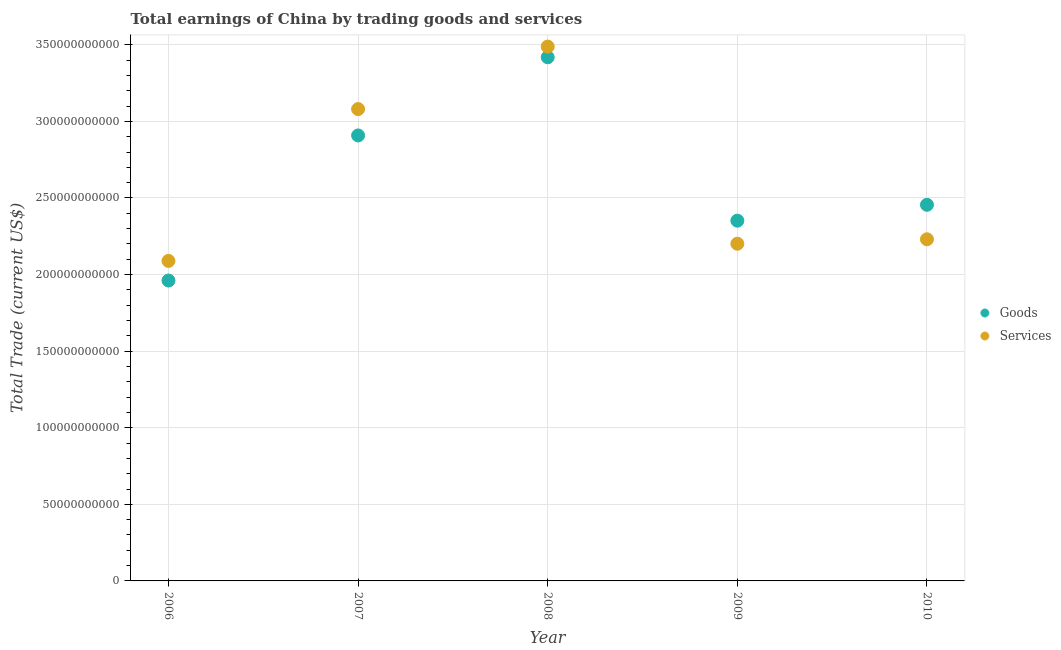What is the amount earned by trading services in 2007?
Provide a succinct answer. 3.08e+11. Across all years, what is the maximum amount earned by trading services?
Offer a terse response. 3.49e+11. Across all years, what is the minimum amount earned by trading goods?
Ensure brevity in your answer.  1.96e+11. In which year was the amount earned by trading goods maximum?
Offer a terse response. 2008. What is the total amount earned by trading goods in the graph?
Provide a succinct answer. 1.31e+12. What is the difference between the amount earned by trading services in 2006 and that in 2010?
Provide a succinct answer. -1.41e+1. What is the difference between the amount earned by trading goods in 2007 and the amount earned by trading services in 2008?
Provide a succinct answer. -5.80e+1. What is the average amount earned by trading services per year?
Your response must be concise. 2.62e+11. In the year 2006, what is the difference between the amount earned by trading goods and amount earned by trading services?
Offer a terse response. -1.28e+1. In how many years, is the amount earned by trading goods greater than 330000000000 US$?
Provide a succinct answer. 1. What is the ratio of the amount earned by trading services in 2007 to that in 2008?
Your response must be concise. 0.88. Is the amount earned by trading goods in 2006 less than that in 2010?
Provide a succinct answer. Yes. Is the difference between the amount earned by trading goods in 2006 and 2007 greater than the difference between the amount earned by trading services in 2006 and 2007?
Your answer should be very brief. Yes. What is the difference between the highest and the second highest amount earned by trading goods?
Your response must be concise. 5.10e+1. What is the difference between the highest and the lowest amount earned by trading services?
Keep it short and to the point. 1.40e+11. Is the sum of the amount earned by trading services in 2009 and 2010 greater than the maximum amount earned by trading goods across all years?
Give a very brief answer. Yes. Does the amount earned by trading goods monotonically increase over the years?
Keep it short and to the point. No. Is the amount earned by trading goods strictly greater than the amount earned by trading services over the years?
Give a very brief answer. No. How many years are there in the graph?
Keep it short and to the point. 5. What is the difference between two consecutive major ticks on the Y-axis?
Make the answer very short. 5.00e+1. Does the graph contain any zero values?
Make the answer very short. No. What is the title of the graph?
Your answer should be compact. Total earnings of China by trading goods and services. Does "National Visitors" appear as one of the legend labels in the graph?
Offer a very short reply. No. What is the label or title of the X-axis?
Offer a terse response. Year. What is the label or title of the Y-axis?
Offer a terse response. Total Trade (current US$). What is the Total Trade (current US$) of Goods in 2006?
Give a very brief answer. 1.96e+11. What is the Total Trade (current US$) in Services in 2006?
Ensure brevity in your answer.  2.09e+11. What is the Total Trade (current US$) of Goods in 2007?
Provide a succinct answer. 2.91e+11. What is the Total Trade (current US$) in Services in 2007?
Ensure brevity in your answer.  3.08e+11. What is the Total Trade (current US$) in Goods in 2008?
Keep it short and to the point. 3.42e+11. What is the Total Trade (current US$) in Services in 2008?
Your response must be concise. 3.49e+11. What is the Total Trade (current US$) in Goods in 2009?
Provide a succinct answer. 2.35e+11. What is the Total Trade (current US$) of Services in 2009?
Ensure brevity in your answer.  2.20e+11. What is the Total Trade (current US$) of Goods in 2010?
Provide a short and direct response. 2.46e+11. What is the Total Trade (current US$) in Services in 2010?
Ensure brevity in your answer.  2.23e+11. Across all years, what is the maximum Total Trade (current US$) of Goods?
Provide a succinct answer. 3.42e+11. Across all years, what is the maximum Total Trade (current US$) of Services?
Ensure brevity in your answer.  3.49e+11. Across all years, what is the minimum Total Trade (current US$) in Goods?
Your answer should be very brief. 1.96e+11. Across all years, what is the minimum Total Trade (current US$) in Services?
Make the answer very short. 2.09e+11. What is the total Total Trade (current US$) in Goods in the graph?
Your answer should be very brief. 1.31e+12. What is the total Total Trade (current US$) of Services in the graph?
Your answer should be very brief. 1.31e+12. What is the difference between the Total Trade (current US$) in Goods in 2006 and that in 2007?
Keep it short and to the point. -9.47e+1. What is the difference between the Total Trade (current US$) of Services in 2006 and that in 2007?
Offer a very short reply. -9.91e+1. What is the difference between the Total Trade (current US$) in Goods in 2006 and that in 2008?
Provide a short and direct response. -1.46e+11. What is the difference between the Total Trade (current US$) in Services in 2006 and that in 2008?
Your answer should be very brief. -1.40e+11. What is the difference between the Total Trade (current US$) in Goods in 2006 and that in 2009?
Give a very brief answer. -3.91e+1. What is the difference between the Total Trade (current US$) in Services in 2006 and that in 2009?
Provide a succinct answer. -1.12e+1. What is the difference between the Total Trade (current US$) in Goods in 2006 and that in 2010?
Offer a terse response. -4.94e+1. What is the difference between the Total Trade (current US$) of Services in 2006 and that in 2010?
Provide a succinct answer. -1.41e+1. What is the difference between the Total Trade (current US$) of Goods in 2007 and that in 2008?
Keep it short and to the point. -5.10e+1. What is the difference between the Total Trade (current US$) in Services in 2007 and that in 2008?
Offer a very short reply. -4.08e+1. What is the difference between the Total Trade (current US$) of Goods in 2007 and that in 2009?
Provide a short and direct response. 5.56e+1. What is the difference between the Total Trade (current US$) of Services in 2007 and that in 2009?
Provide a short and direct response. 8.79e+1. What is the difference between the Total Trade (current US$) of Goods in 2007 and that in 2010?
Give a very brief answer. 4.53e+1. What is the difference between the Total Trade (current US$) in Services in 2007 and that in 2010?
Offer a terse response. 8.50e+1. What is the difference between the Total Trade (current US$) in Goods in 2008 and that in 2009?
Ensure brevity in your answer.  1.07e+11. What is the difference between the Total Trade (current US$) in Services in 2008 and that in 2009?
Your response must be concise. 1.29e+11. What is the difference between the Total Trade (current US$) of Goods in 2008 and that in 2010?
Offer a terse response. 9.63e+1. What is the difference between the Total Trade (current US$) of Services in 2008 and that in 2010?
Make the answer very short. 1.26e+11. What is the difference between the Total Trade (current US$) of Goods in 2009 and that in 2010?
Offer a terse response. -1.04e+1. What is the difference between the Total Trade (current US$) of Services in 2009 and that in 2010?
Your response must be concise. -2.89e+09. What is the difference between the Total Trade (current US$) of Goods in 2006 and the Total Trade (current US$) of Services in 2007?
Offer a terse response. -1.12e+11. What is the difference between the Total Trade (current US$) of Goods in 2006 and the Total Trade (current US$) of Services in 2008?
Offer a terse response. -1.53e+11. What is the difference between the Total Trade (current US$) in Goods in 2006 and the Total Trade (current US$) in Services in 2009?
Provide a short and direct response. -2.40e+1. What is the difference between the Total Trade (current US$) in Goods in 2006 and the Total Trade (current US$) in Services in 2010?
Provide a succinct answer. -2.69e+1. What is the difference between the Total Trade (current US$) of Goods in 2007 and the Total Trade (current US$) of Services in 2008?
Provide a short and direct response. -5.80e+1. What is the difference between the Total Trade (current US$) of Goods in 2007 and the Total Trade (current US$) of Services in 2009?
Give a very brief answer. 7.07e+1. What is the difference between the Total Trade (current US$) of Goods in 2007 and the Total Trade (current US$) of Services in 2010?
Your answer should be compact. 6.78e+1. What is the difference between the Total Trade (current US$) in Goods in 2008 and the Total Trade (current US$) in Services in 2009?
Your answer should be compact. 1.22e+11. What is the difference between the Total Trade (current US$) of Goods in 2008 and the Total Trade (current US$) of Services in 2010?
Provide a succinct answer. 1.19e+11. What is the difference between the Total Trade (current US$) in Goods in 2009 and the Total Trade (current US$) in Services in 2010?
Give a very brief answer. 1.22e+1. What is the average Total Trade (current US$) of Goods per year?
Make the answer very short. 2.62e+11. What is the average Total Trade (current US$) of Services per year?
Provide a short and direct response. 2.62e+11. In the year 2006, what is the difference between the Total Trade (current US$) in Goods and Total Trade (current US$) in Services?
Your answer should be very brief. -1.28e+1. In the year 2007, what is the difference between the Total Trade (current US$) in Goods and Total Trade (current US$) in Services?
Your response must be concise. -1.72e+1. In the year 2008, what is the difference between the Total Trade (current US$) in Goods and Total Trade (current US$) in Services?
Your response must be concise. -6.97e+09. In the year 2009, what is the difference between the Total Trade (current US$) of Goods and Total Trade (current US$) of Services?
Your response must be concise. 1.50e+1. In the year 2010, what is the difference between the Total Trade (current US$) of Goods and Total Trade (current US$) of Services?
Keep it short and to the point. 2.25e+1. What is the ratio of the Total Trade (current US$) in Goods in 2006 to that in 2007?
Provide a succinct answer. 0.67. What is the ratio of the Total Trade (current US$) in Services in 2006 to that in 2007?
Your response must be concise. 0.68. What is the ratio of the Total Trade (current US$) in Goods in 2006 to that in 2008?
Your answer should be compact. 0.57. What is the ratio of the Total Trade (current US$) of Services in 2006 to that in 2008?
Provide a short and direct response. 0.6. What is the ratio of the Total Trade (current US$) of Goods in 2006 to that in 2009?
Provide a succinct answer. 0.83. What is the ratio of the Total Trade (current US$) in Services in 2006 to that in 2009?
Offer a terse response. 0.95. What is the ratio of the Total Trade (current US$) of Goods in 2006 to that in 2010?
Provide a short and direct response. 0.8. What is the ratio of the Total Trade (current US$) of Services in 2006 to that in 2010?
Offer a very short reply. 0.94. What is the ratio of the Total Trade (current US$) in Goods in 2007 to that in 2008?
Your response must be concise. 0.85. What is the ratio of the Total Trade (current US$) in Services in 2007 to that in 2008?
Your answer should be compact. 0.88. What is the ratio of the Total Trade (current US$) in Goods in 2007 to that in 2009?
Give a very brief answer. 1.24. What is the ratio of the Total Trade (current US$) of Services in 2007 to that in 2009?
Your response must be concise. 1.4. What is the ratio of the Total Trade (current US$) of Goods in 2007 to that in 2010?
Give a very brief answer. 1.18. What is the ratio of the Total Trade (current US$) of Services in 2007 to that in 2010?
Provide a succinct answer. 1.38. What is the ratio of the Total Trade (current US$) in Goods in 2008 to that in 2009?
Ensure brevity in your answer.  1.45. What is the ratio of the Total Trade (current US$) of Services in 2008 to that in 2009?
Provide a succinct answer. 1.58. What is the ratio of the Total Trade (current US$) of Goods in 2008 to that in 2010?
Your response must be concise. 1.39. What is the ratio of the Total Trade (current US$) in Services in 2008 to that in 2010?
Give a very brief answer. 1.56. What is the ratio of the Total Trade (current US$) in Goods in 2009 to that in 2010?
Ensure brevity in your answer.  0.96. What is the ratio of the Total Trade (current US$) in Services in 2009 to that in 2010?
Your response must be concise. 0.99. What is the difference between the highest and the second highest Total Trade (current US$) of Goods?
Make the answer very short. 5.10e+1. What is the difference between the highest and the second highest Total Trade (current US$) of Services?
Offer a terse response. 4.08e+1. What is the difference between the highest and the lowest Total Trade (current US$) in Goods?
Offer a very short reply. 1.46e+11. What is the difference between the highest and the lowest Total Trade (current US$) in Services?
Offer a terse response. 1.40e+11. 